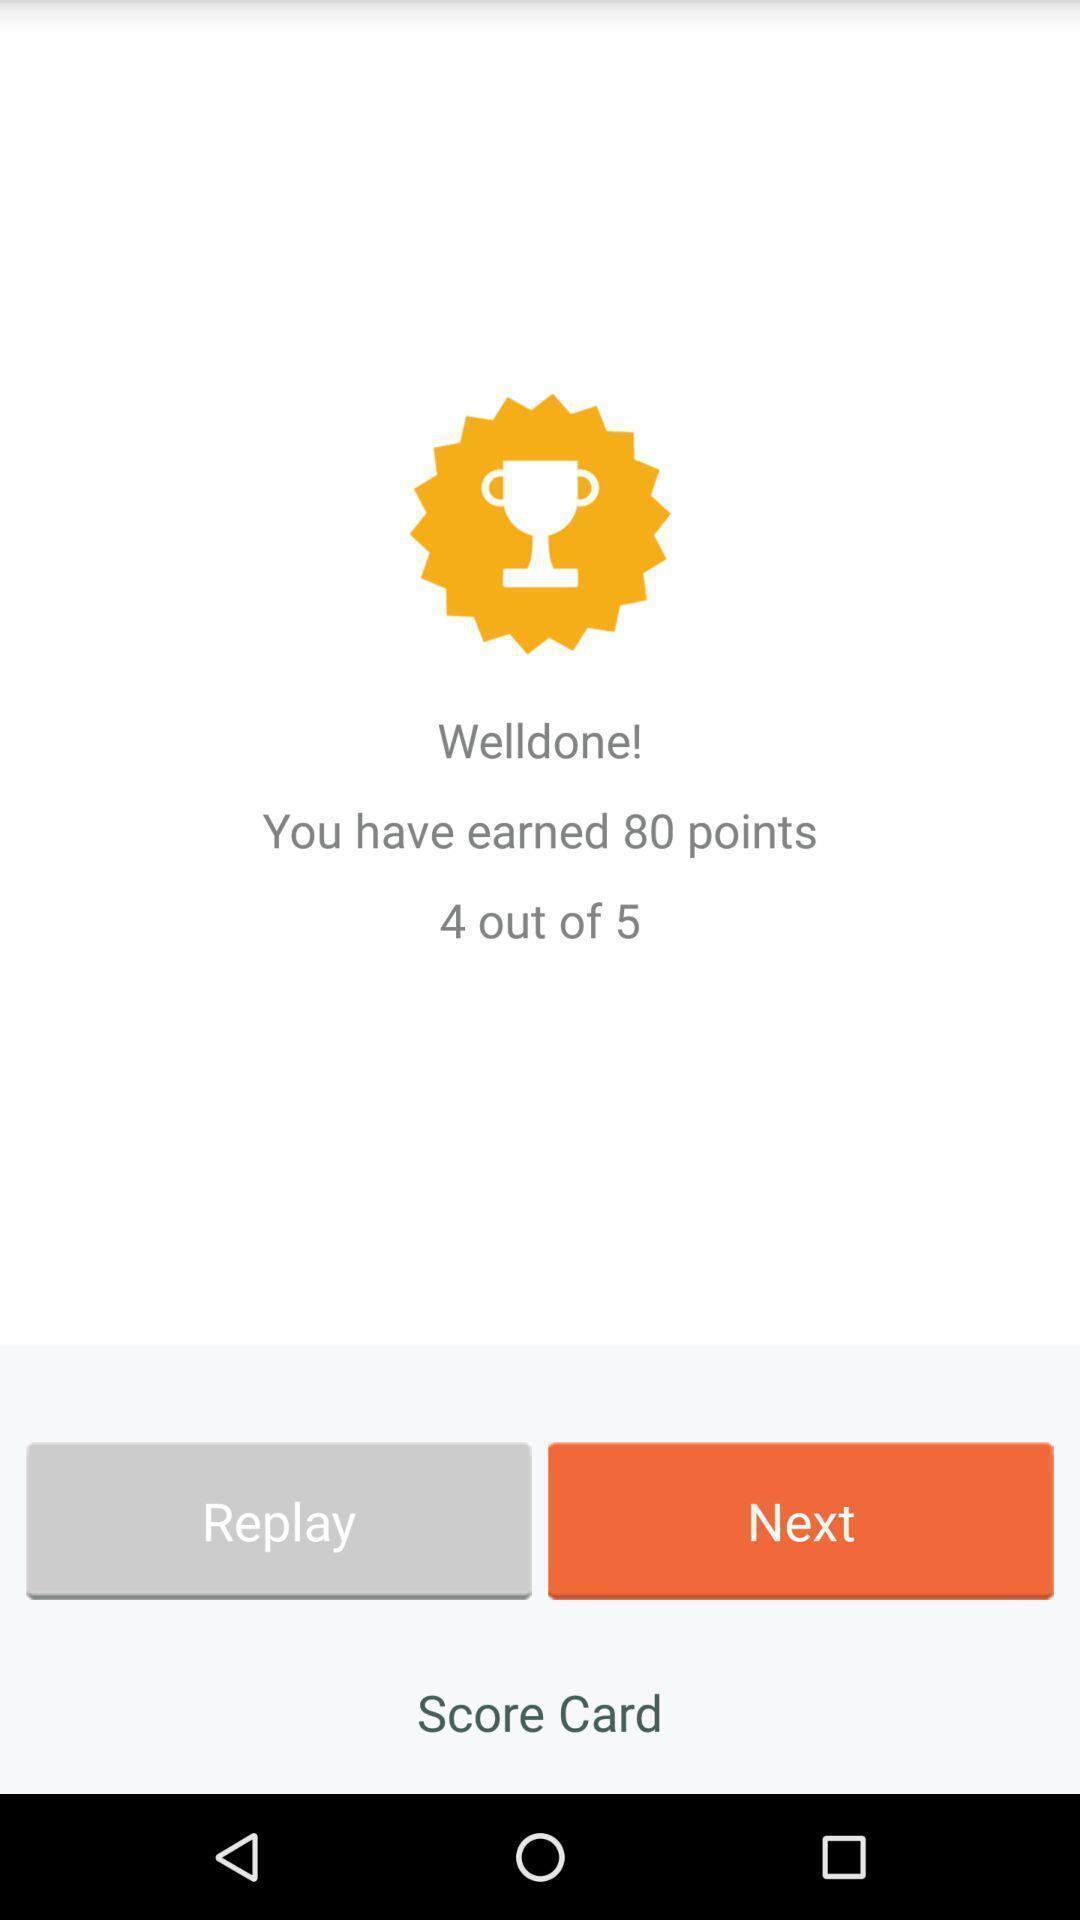What details can you identify in this image? Page showing option like replay. 